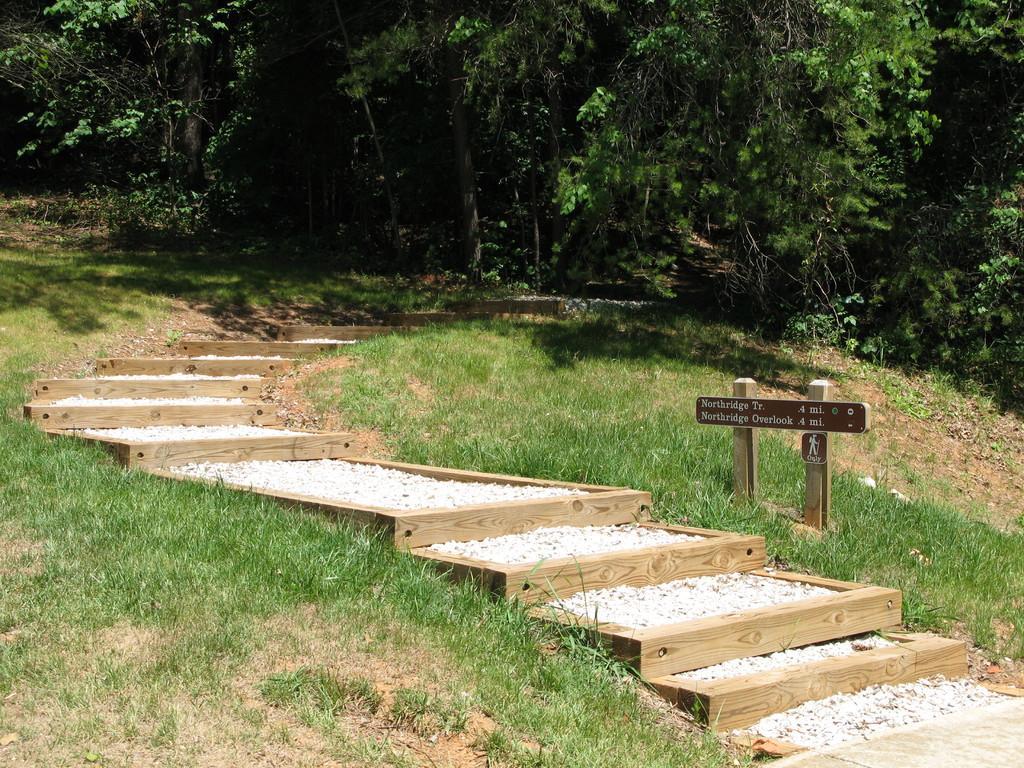Please provide a concise description of this image. In this image we can see some plants, trees, grass, wooden stairs, stones, also we can see a board with some text written on it, is attached to two wooden poles. 